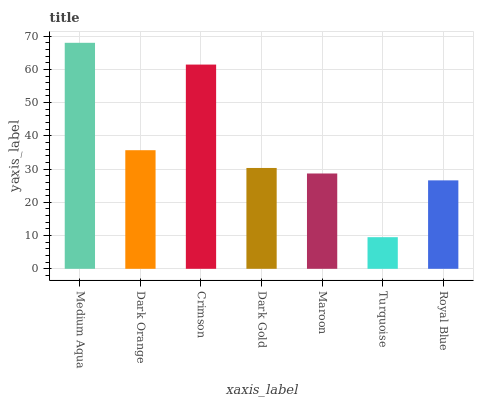Is Turquoise the minimum?
Answer yes or no. Yes. Is Medium Aqua the maximum?
Answer yes or no. Yes. Is Dark Orange the minimum?
Answer yes or no. No. Is Dark Orange the maximum?
Answer yes or no. No. Is Medium Aqua greater than Dark Orange?
Answer yes or no. Yes. Is Dark Orange less than Medium Aqua?
Answer yes or no. Yes. Is Dark Orange greater than Medium Aqua?
Answer yes or no. No. Is Medium Aqua less than Dark Orange?
Answer yes or no. No. Is Dark Gold the high median?
Answer yes or no. Yes. Is Dark Gold the low median?
Answer yes or no. Yes. Is Maroon the high median?
Answer yes or no. No. Is Medium Aqua the low median?
Answer yes or no. No. 